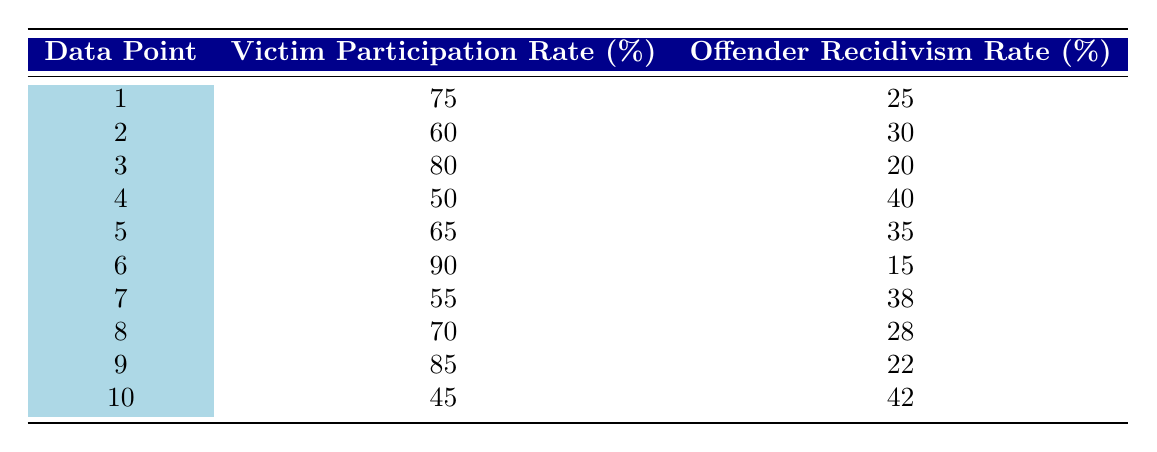What is the offender recidivism rate when the victim participation rate is 90%? Referring to the table, under the victim participation rate of 90%, the offender recidivism rate is listed as 15%.
Answer: 15 What is the victim participation rate corresponding to the highest offender recidivism rate? By examining the table, the highest offender recidivism rate is 42%, which corresponds to a victim participation rate of 45%.
Answer: 45 What is the average victim participation rate of all data points? To find the average, sum the victim participation rates (75 + 60 + 80 + 50 + 65 + 90 + 55 + 70 + 85 + 45 =  765) and divide by the number of data points (10). Thus, the average is 765/10 = 76.5.
Answer: 76.5 Is there a data point where both victim participation and offender recidivism rates are above 60%? Referring to the table, there are no data points where both values exceed 60%. The highest victim participation with offender recidivism over 60% is 60% victim participation with 30% recidivism.
Answer: No Which two victim participation rates yield the lowest recidivism rates and what are those rates? The two lowest recidivism rates are 15% (90% victim participation) and 20% (80% victim participation). Thus, the rates yielding the lowest recidivism rates are 90% and 80%.
Answer: 90% and 80% with rates 15% and 20% respectively 